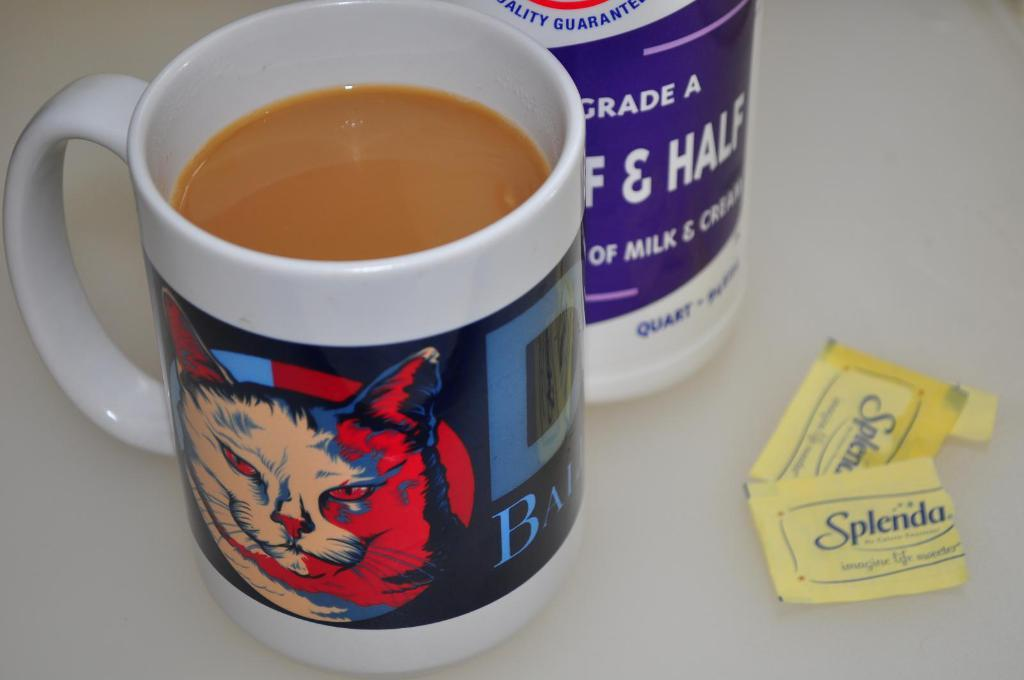<image>
Give a short and clear explanation of the subsequent image. A full mug of coffee is sitting next to some open packages of Splenda. 